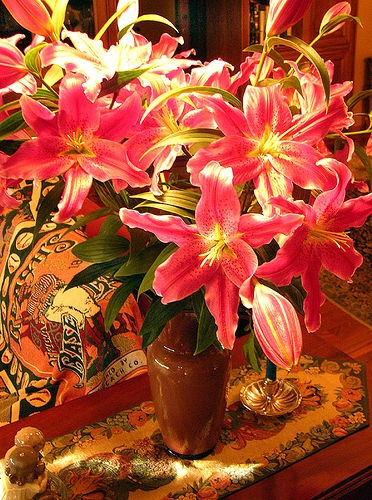Describe the objects in this image and their specific colors. I can see a vase in black, maroon, and brown tones in this image. 